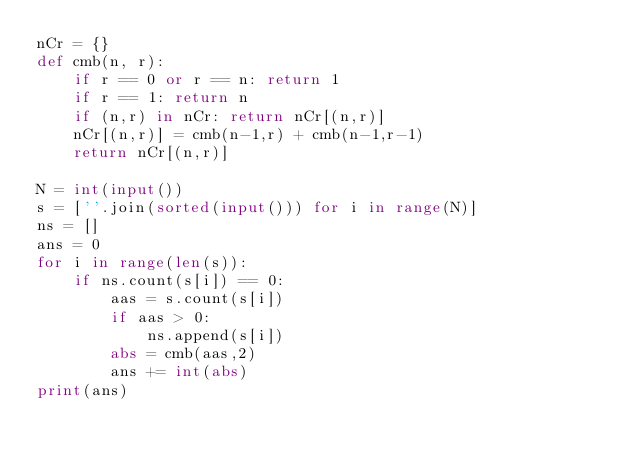Convert code to text. <code><loc_0><loc_0><loc_500><loc_500><_Python_>nCr = {}
def cmb(n, r):
    if r == 0 or r == n: return 1
    if r == 1: return n
    if (n,r) in nCr: return nCr[(n,r)]
    nCr[(n,r)] = cmb(n-1,r) + cmb(n-1,r-1)
    return nCr[(n,r)]

N = int(input())
s = [''.join(sorted(input())) for i in range(N)]
ns = []
ans = 0
for i in range(len(s)):
    if ns.count(s[i]) == 0:
        aas = s.count(s[i])
        if aas > 0:
            ns.append(s[i])
        abs = cmb(aas,2)
        ans += int(abs)
print(ans)</code> 